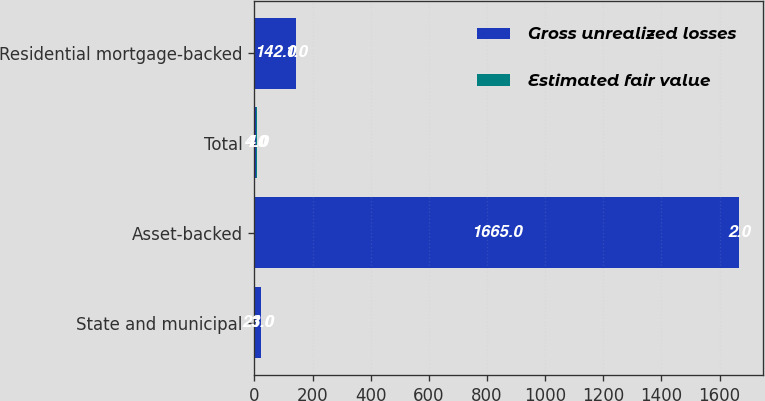<chart> <loc_0><loc_0><loc_500><loc_500><stacked_bar_chart><ecel><fcel>State and municipal<fcel>Asset-backed<fcel>Total<fcel>Residential mortgage-backed<nl><fcel>Gross unrealized losses<fcel>23<fcel>1665<fcel>4<fcel>142<nl><fcel>Estimated fair value<fcel>1<fcel>2<fcel>4<fcel>1<nl></chart> 